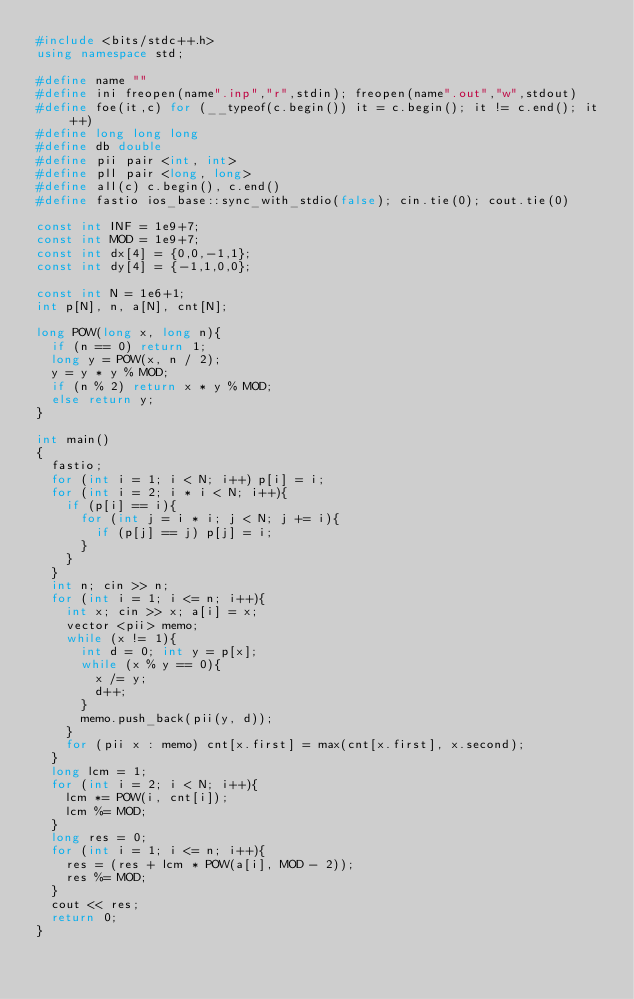<code> <loc_0><loc_0><loc_500><loc_500><_C++_>#include <bits/stdc++.h>
using namespace std;

#define name ""
#define ini freopen(name".inp","r",stdin); freopen(name".out","w",stdout)
#define foe(it,c) for (__typeof(c.begin()) it = c.begin(); it != c.end(); it++)
#define long long long 
#define db double 
#define pii pair <int, int>
#define pll pair <long, long>
#define all(c) c.begin(), c.end()
#define fastio ios_base::sync_with_stdio(false); cin.tie(0); cout.tie(0)

const int INF = 1e9+7;
const int MOD = 1e9+7;
const int dx[4] = {0,0,-1,1};
const int dy[4] = {-1,1,0,0};

const int N = 1e6+1;
int p[N], n, a[N], cnt[N];

long POW(long x, long n){
  if (n == 0) return 1;
  long y = POW(x, n / 2);
  y = y * y % MOD;
  if (n % 2) return x * y % MOD;
  else return y;
}

int main()
{
  fastio;
  for (int i = 1; i < N; i++) p[i] = i;
  for (int i = 2; i * i < N; i++){
    if (p[i] == i){
      for (int j = i * i; j < N; j += i){
        if (p[j] == j) p[j] = i;
      }
    }
  }
  int n; cin >> n;
  for (int i = 1; i <= n; i++){
    int x; cin >> x; a[i] = x;
    vector <pii> memo;
    while (x != 1){
      int d = 0; int y = p[x];
      while (x % y == 0){
        x /= y;
        d++;
      }  
      memo.push_back(pii(y, d));
    }
    for (pii x : memo) cnt[x.first] = max(cnt[x.first], x.second);
  }
  long lcm = 1;
  for (int i = 2; i < N; i++){
    lcm *= POW(i, cnt[i]);
    lcm %= MOD;
  }
  long res = 0;
  for (int i = 1; i <= n; i++){
    res = (res + lcm * POW(a[i], MOD - 2));
    res %= MOD;
  }
  cout << res;
  return 0;
}</code> 